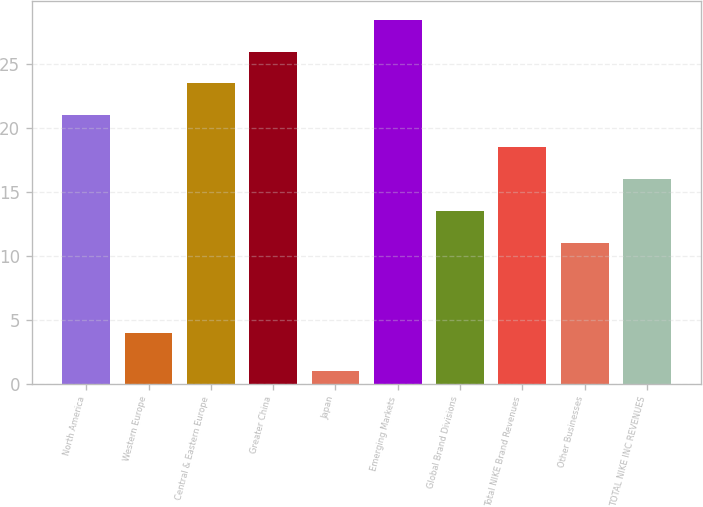Convert chart. <chart><loc_0><loc_0><loc_500><loc_500><bar_chart><fcel>North America<fcel>Western Europe<fcel>Central & Eastern Europe<fcel>Greater China<fcel>Japan<fcel>Emerging Markets<fcel>Global Brand Divisions<fcel>Total NIKE Brand Revenues<fcel>Other Businesses<fcel>TOTAL NIKE INC REVENUES<nl><fcel>21<fcel>4<fcel>23.5<fcel>26<fcel>1<fcel>28.5<fcel>13.5<fcel>18.5<fcel>11<fcel>16<nl></chart> 